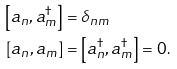Convert formula to latex. <formula><loc_0><loc_0><loc_500><loc_500>\left [ a _ { n } , a _ { m } ^ { \dagger } \right ] & = \delta _ { n m } \\ \left [ a _ { n } , a _ { m } \right ] & = \left [ a _ { n } ^ { \dagger } , a _ { m } ^ { \dagger } \right ] = 0 .</formula> 